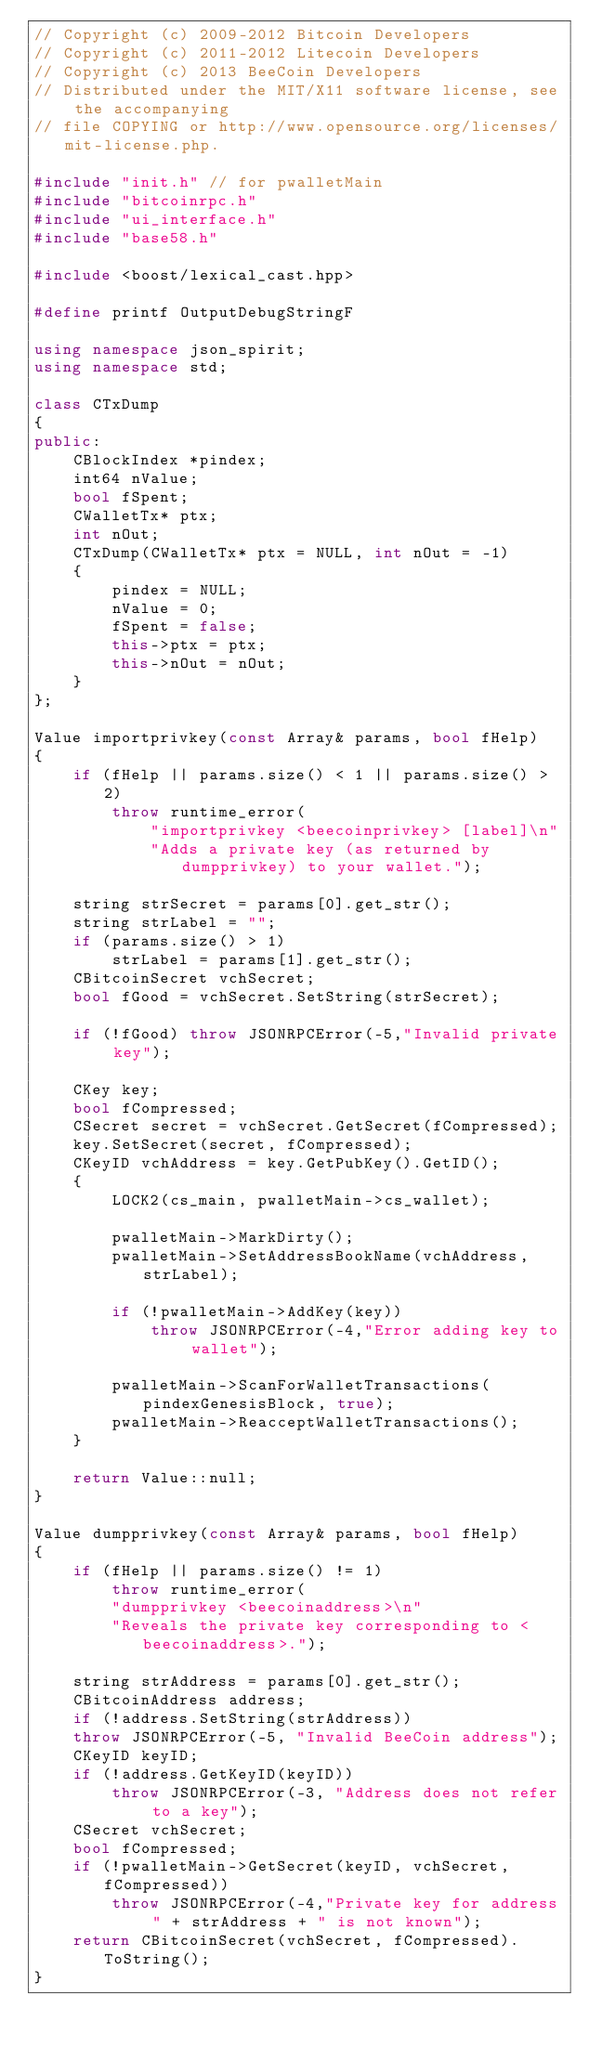<code> <loc_0><loc_0><loc_500><loc_500><_C++_>// Copyright (c) 2009-2012 Bitcoin Developers
// Copyright (c) 2011-2012 Litecoin Developers
// Copyright (c) 2013 BeeCoin Developers
// Distributed under the MIT/X11 software license, see the accompanying
// file COPYING or http://www.opensource.org/licenses/mit-license.php.

#include "init.h" // for pwalletMain
#include "bitcoinrpc.h"
#include "ui_interface.h"
#include "base58.h"

#include <boost/lexical_cast.hpp>

#define printf OutputDebugStringF

using namespace json_spirit;
using namespace std;

class CTxDump
{
public:
    CBlockIndex *pindex;
    int64 nValue;
    bool fSpent;
    CWalletTx* ptx;
    int nOut;
    CTxDump(CWalletTx* ptx = NULL, int nOut = -1)
    {
        pindex = NULL;
        nValue = 0;
        fSpent = false;
        this->ptx = ptx;
        this->nOut = nOut;
    }
};

Value importprivkey(const Array& params, bool fHelp)
{
    if (fHelp || params.size() < 1 || params.size() > 2)
        throw runtime_error(
            "importprivkey <beecoinprivkey> [label]\n"
            "Adds a private key (as returned by dumpprivkey) to your wallet.");

    string strSecret = params[0].get_str();
    string strLabel = "";
    if (params.size() > 1)
        strLabel = params[1].get_str();
    CBitcoinSecret vchSecret;
    bool fGood = vchSecret.SetString(strSecret);

    if (!fGood) throw JSONRPCError(-5,"Invalid private key");

    CKey key;
    bool fCompressed;
    CSecret secret = vchSecret.GetSecret(fCompressed);
    key.SetSecret(secret, fCompressed);
    CKeyID vchAddress = key.GetPubKey().GetID();
    {
        LOCK2(cs_main, pwalletMain->cs_wallet);

        pwalletMain->MarkDirty();
        pwalletMain->SetAddressBookName(vchAddress, strLabel);

        if (!pwalletMain->AddKey(key))
            throw JSONRPCError(-4,"Error adding key to wallet");

        pwalletMain->ScanForWalletTransactions(pindexGenesisBlock, true);
        pwalletMain->ReacceptWalletTransactions();
    }

    return Value::null;
}

Value dumpprivkey(const Array& params, bool fHelp)
{
    if (fHelp || params.size() != 1)
        throw runtime_error(
        "dumpprivkey <beecoinaddress>\n"
        "Reveals the private key corresponding to <beecoinaddress>.");

    string strAddress = params[0].get_str();
    CBitcoinAddress address;
    if (!address.SetString(strAddress))
    throw JSONRPCError(-5, "Invalid BeeCoin address");
    CKeyID keyID;
    if (!address.GetKeyID(keyID))
        throw JSONRPCError(-3, "Address does not refer to a key");
    CSecret vchSecret;
    bool fCompressed;
    if (!pwalletMain->GetSecret(keyID, vchSecret, fCompressed))
        throw JSONRPCError(-4,"Private key for address " + strAddress + " is not known");
    return CBitcoinSecret(vchSecret, fCompressed).ToString();
}
</code> 